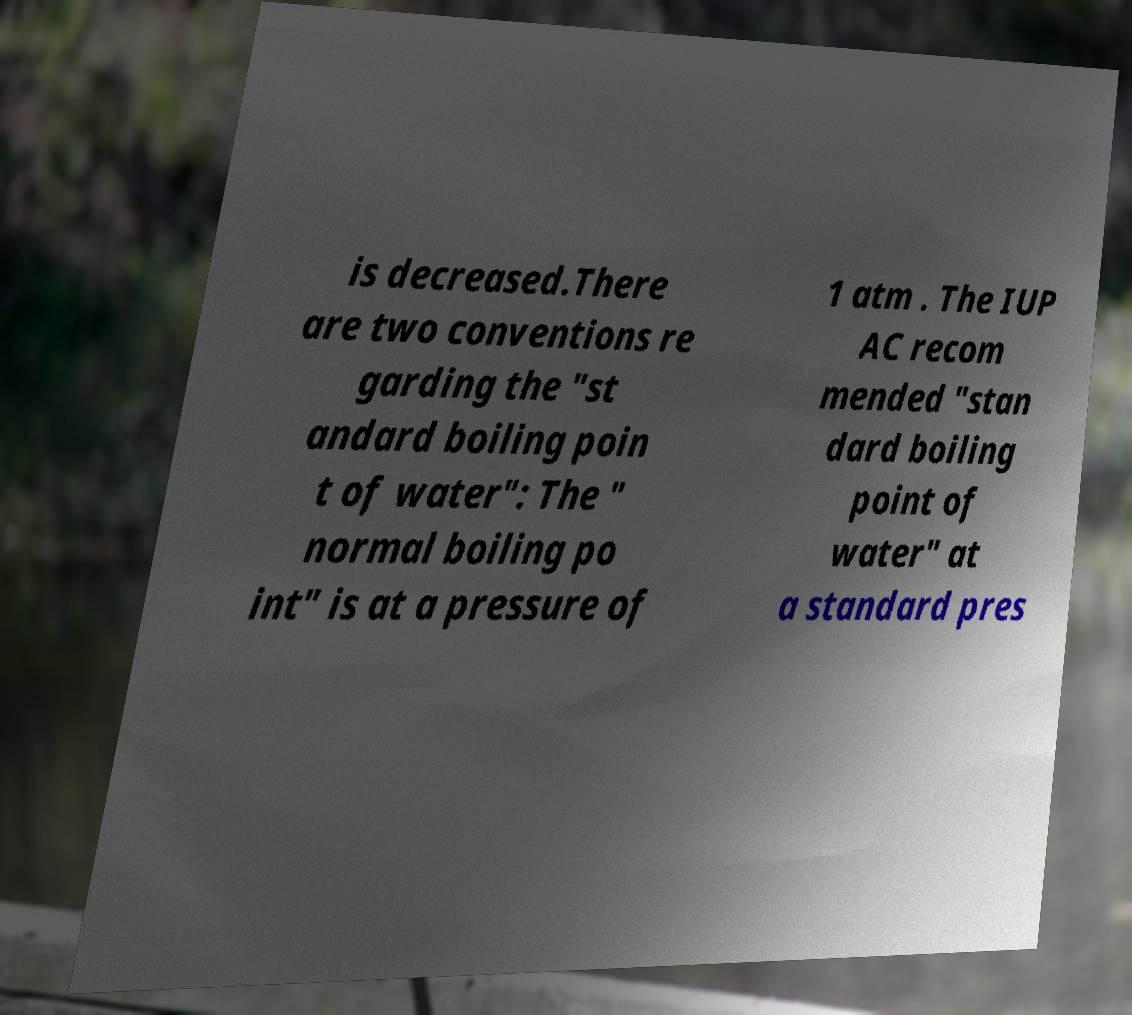For documentation purposes, I need the text within this image transcribed. Could you provide that? is decreased.There are two conventions re garding the "st andard boiling poin t of water": The " normal boiling po int" is at a pressure of 1 atm . The IUP AC recom mended "stan dard boiling point of water" at a standard pres 